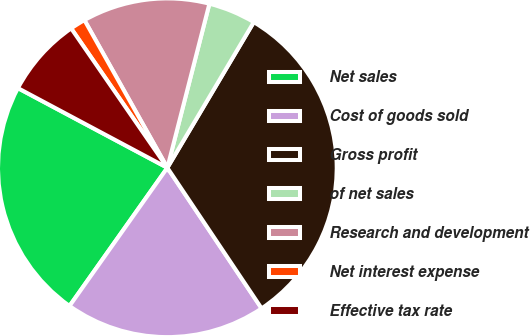Convert chart. <chart><loc_0><loc_0><loc_500><loc_500><pie_chart><fcel>Net sales<fcel>Cost of goods sold<fcel>Gross profit<fcel>of net sales<fcel>Research and development<fcel>Net interest expense<fcel>Effective tax rate<nl><fcel>22.99%<fcel>19.2%<fcel>32.08%<fcel>4.53%<fcel>12.14%<fcel>1.47%<fcel>7.59%<nl></chart> 